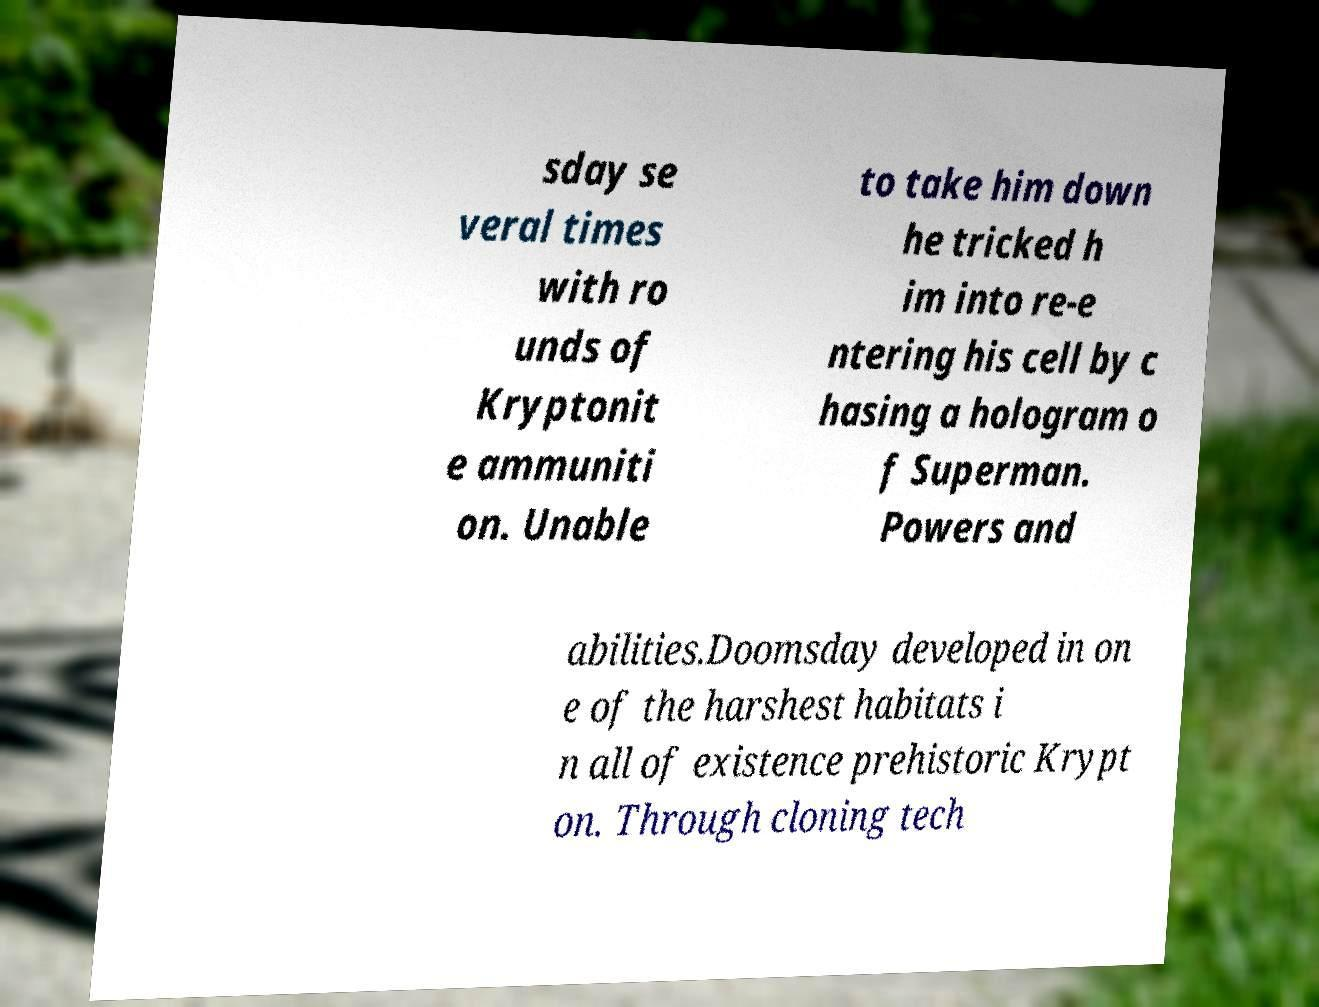What messages or text are displayed in this image? I need them in a readable, typed format. sday se veral times with ro unds of Kryptonit e ammuniti on. Unable to take him down he tricked h im into re-e ntering his cell by c hasing a hologram o f Superman. Powers and abilities.Doomsday developed in on e of the harshest habitats i n all of existence prehistoric Krypt on. Through cloning tech 